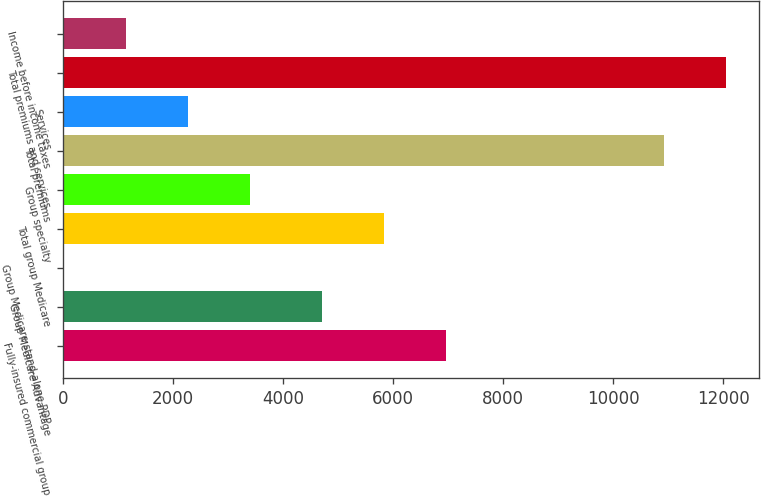<chart> <loc_0><loc_0><loc_500><loc_500><bar_chart><fcel>Fully-insured commercial group<fcel>Group Medicare Advantage<fcel>Group Medicare stand-alone PDP<fcel>Total group Medicare<fcel>Group specialty<fcel>Total premiums<fcel>Services<fcel>Total premiums and services<fcel>Income before income taxes<nl><fcel>6965.8<fcel>4710<fcel>8<fcel>5837.9<fcel>3391.7<fcel>10930<fcel>2263.8<fcel>12057.9<fcel>1135.9<nl></chart> 